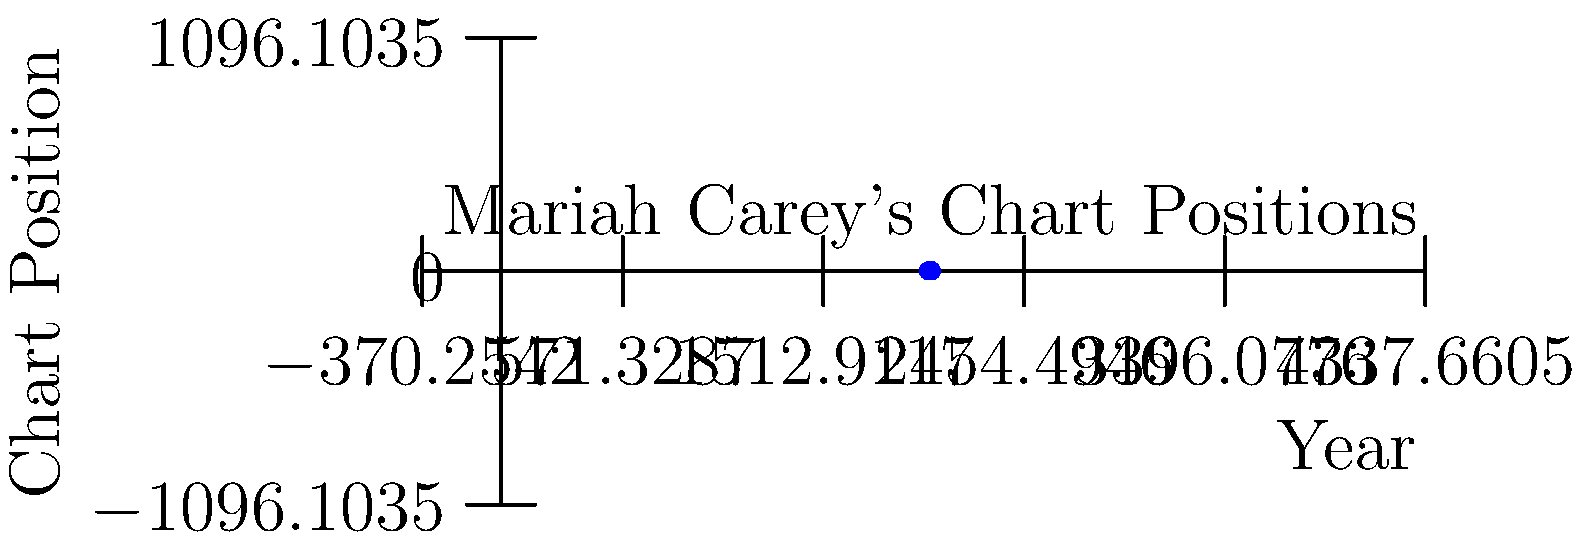Based on the graph showing Mariah Carey's chart positions over time, in which year did she achieve her highest chart position after experiencing a dip in 2014? To answer this question, we need to analyze Mariah Carey's chart positions after 2014:

1. In 2014, we can see that Mariah's chart position dipped to 5th place.
2. After 2014, there are two data points to consider:
   - In 2017, her chart position improved to 4th place.
   - In 2020, her chart position reached 1st place.
3. Between these two points, 2020 shows the highest chart position (1st place).
4. This is also the highest possible chart position overall.

Therefore, 2020 is the year when Mariah Carey achieved her highest chart position after the dip in 2014.
Answer: 2020 